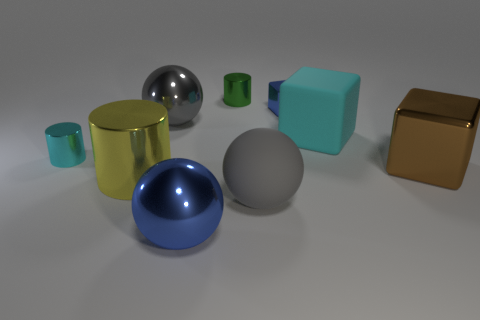Is there anything else that is the same color as the large rubber block? The large rubber block is a distinct aqua color. While observing the other objects, there is a smaller cube with a similar shade of aqua to the left of the large rubber block. 